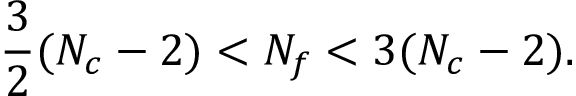<formula> <loc_0><loc_0><loc_500><loc_500>\frac { 3 } { 2 } ( N _ { c } - 2 ) < N _ { f } < 3 ( N _ { c } - 2 ) .</formula> 